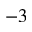Convert formula to latex. <formula><loc_0><loc_0><loc_500><loc_500>^ { - 3 }</formula> 